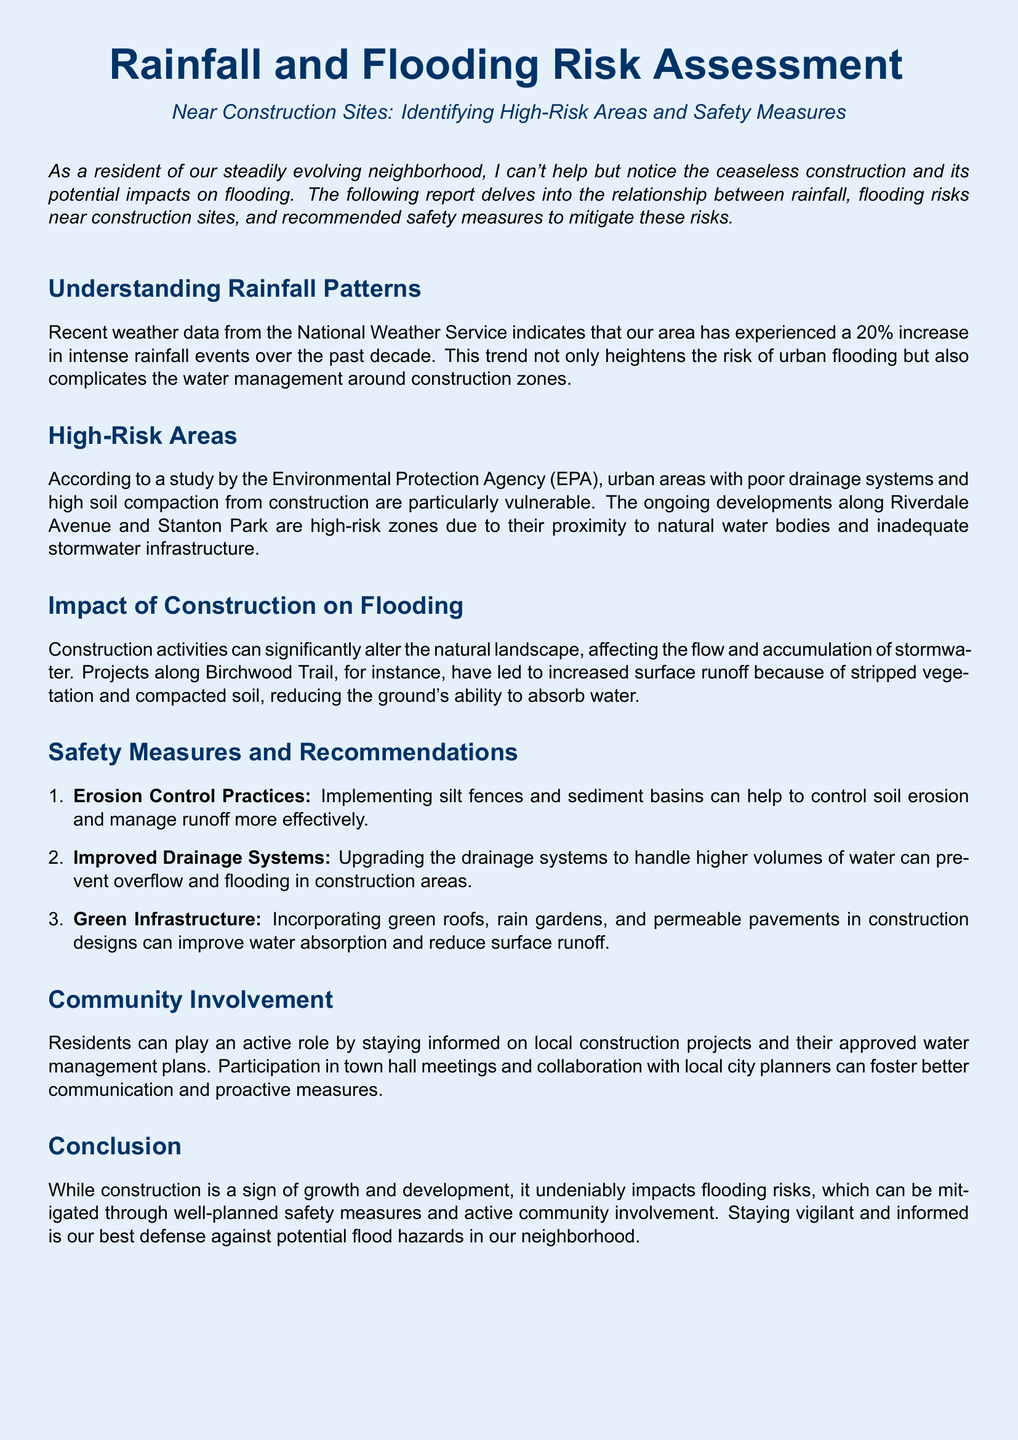What is the increase in intense rainfall events over the past decade? The document states that there has been a 20% increase in intense rainfall events over the past decade.
Answer: 20% Which areas are identified as high-risk zones? The report highlights Riverdale Avenue and Stanton Park as high-risk zones due to their proximity to natural water bodies and inadequate stormwater infrastructure.
Answer: Riverdale Avenue and Stanton Park What is one impact of construction on flooding? The document mentions that construction activities significantly alter the natural landscape, affecting the flow and accumulation of stormwater, particularly due to increased surface runoff.
Answer: Increased surface runoff Name one safety measure recommended in the report. The report suggests erosion control practices such as implementing silt fences and sediment basins.
Answer: Erosion control practices How can residents get involved in mitigating flooding risks? The document states that residents can stay informed on local construction projects and participate in town hall meetings to foster better communication and proactive measures.
Answer: Participate in town hall meetings 